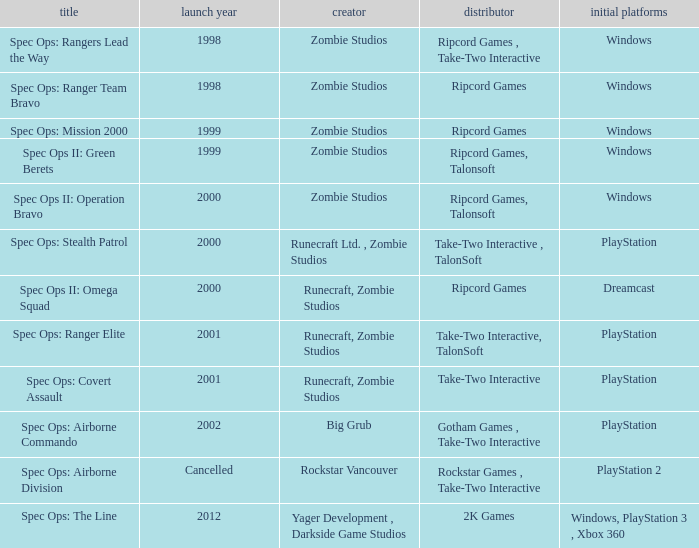Which developer has a year of cancelled releases? Rockstar Vancouver. 